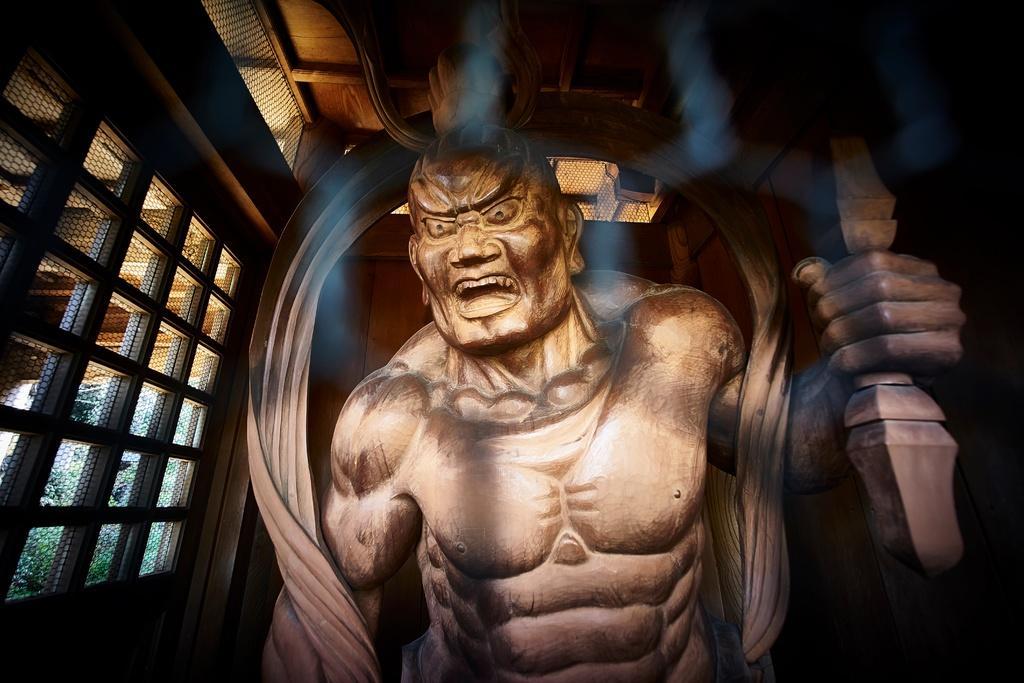Please provide a concise description of this image. In the foreground, I can see a person's sculpture. In the background, I can see windows and walls. This image taken, maybe in a hall. 